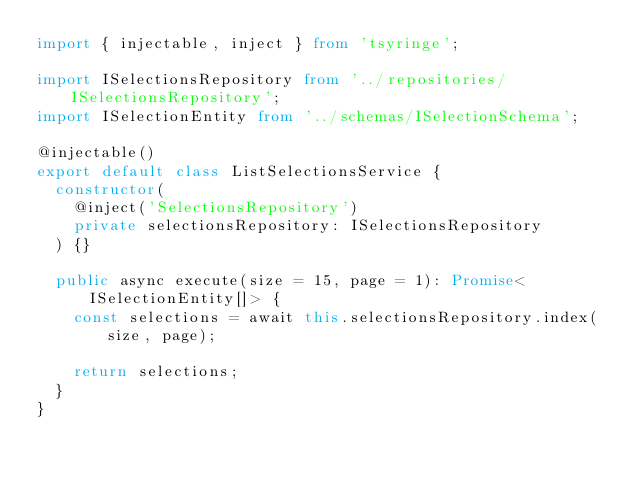<code> <loc_0><loc_0><loc_500><loc_500><_TypeScript_>import { injectable, inject } from 'tsyringe';

import ISelectionsRepository from '../repositories/ISelectionsRepository';
import ISelectionEntity from '../schemas/ISelectionSchema';

@injectable()
export default class ListSelectionsService {
  constructor(
    @inject('SelectionsRepository')
    private selectionsRepository: ISelectionsRepository
  ) {}

  public async execute(size = 15, page = 1): Promise<ISelectionEntity[]> {
    const selections = await this.selectionsRepository.index(size, page);

    return selections;
  }
}
</code> 